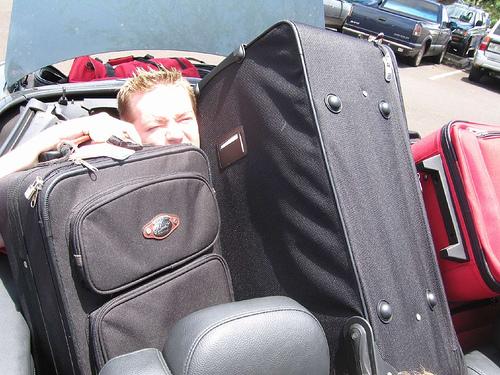What is the boy clutching?
Answer briefly. Suitcase. What kind of car is this?
Keep it brief. Convertible. What is laying on top of the boy?
Be succinct. Suitcases. 